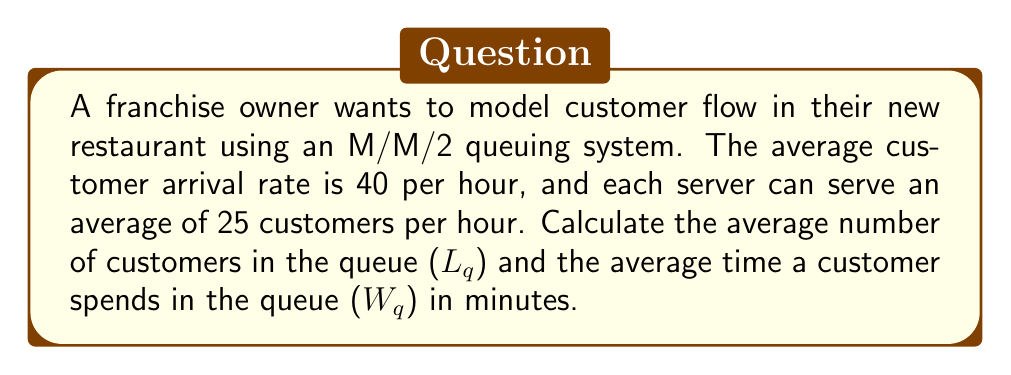Help me with this question. To solve this problem, we'll use the M/M/2 queuing theory model. Let's follow these steps:

1. Define the parameters:
   $\lambda$ = arrival rate = 40 customers/hour
   $\mu$ = service rate per server = 25 customers/hour
   $c$ = number of servers = 2

2. Calculate the system utilization ($\rho$):
   $$\rho = \frac{\lambda}{c\mu} = \frac{40}{2 \cdot 25} = 0.8$$

3. Calculate $P_0$, the probability of an empty system:
   $$P_0 = \left[\sum_{n=0}^{c-1}\frac{(c\rho)^n}{n!} + \frac{(c\rho)^c}{c!(1-\rho)}\right]^{-1}$$
   $$P_0 = \left[1 + \frac{2 \cdot 0.8}{1!} + \frac{(2 \cdot 0.8)^2}{2!(1-0.8)}\right]^{-1} = 0.1111$$

4. Calculate $L_q$, the average number of customers in the queue:
   $$L_q = \frac{P_0(c\rho)^c\rho}{c!(1-\rho)^2}$$
   $$L_q = \frac{0.1111 \cdot (2 \cdot 0.8)^2 \cdot 0.8}{2!(1-0.8)^2} = 2.8444$$

5. Calculate $W_q$, the average time a customer spends in the queue:
   $$W_q = \frac{L_q}{\lambda}$$
   $$W_q = \frac{2.8444}{40} = 0.0711 \text{ hours} = 4.2667 \text{ minutes}$$
Answer: $L_q = 2.8444$ customers, $W_q = 4.2667$ minutes 